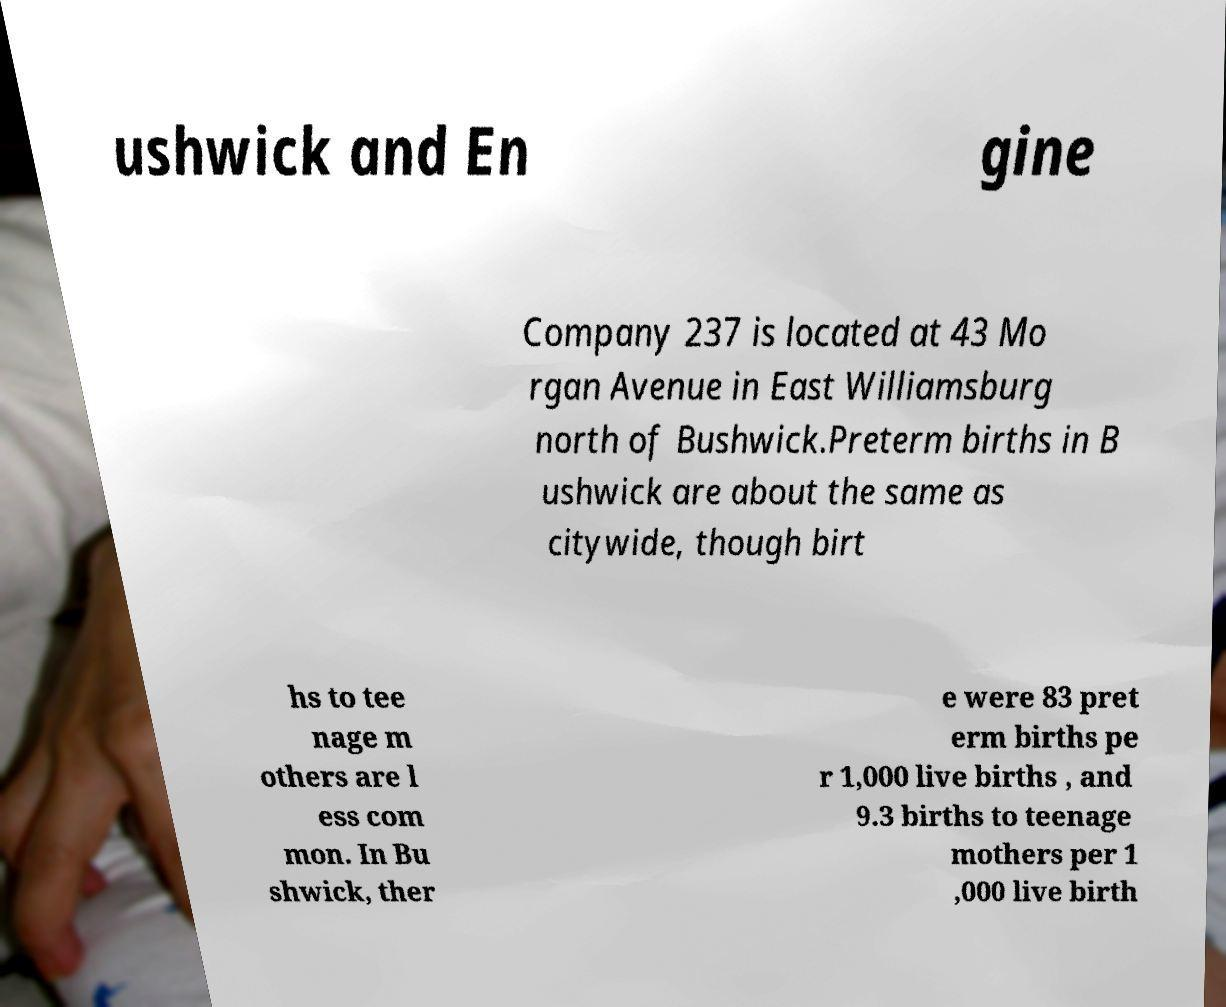Please read and relay the text visible in this image. What does it say? ushwick and En gine Company 237 is located at 43 Mo rgan Avenue in East Williamsburg north of Bushwick.Preterm births in B ushwick are about the same as citywide, though birt hs to tee nage m others are l ess com mon. In Bu shwick, ther e were 83 pret erm births pe r 1,000 live births , and 9.3 births to teenage mothers per 1 ,000 live birth 